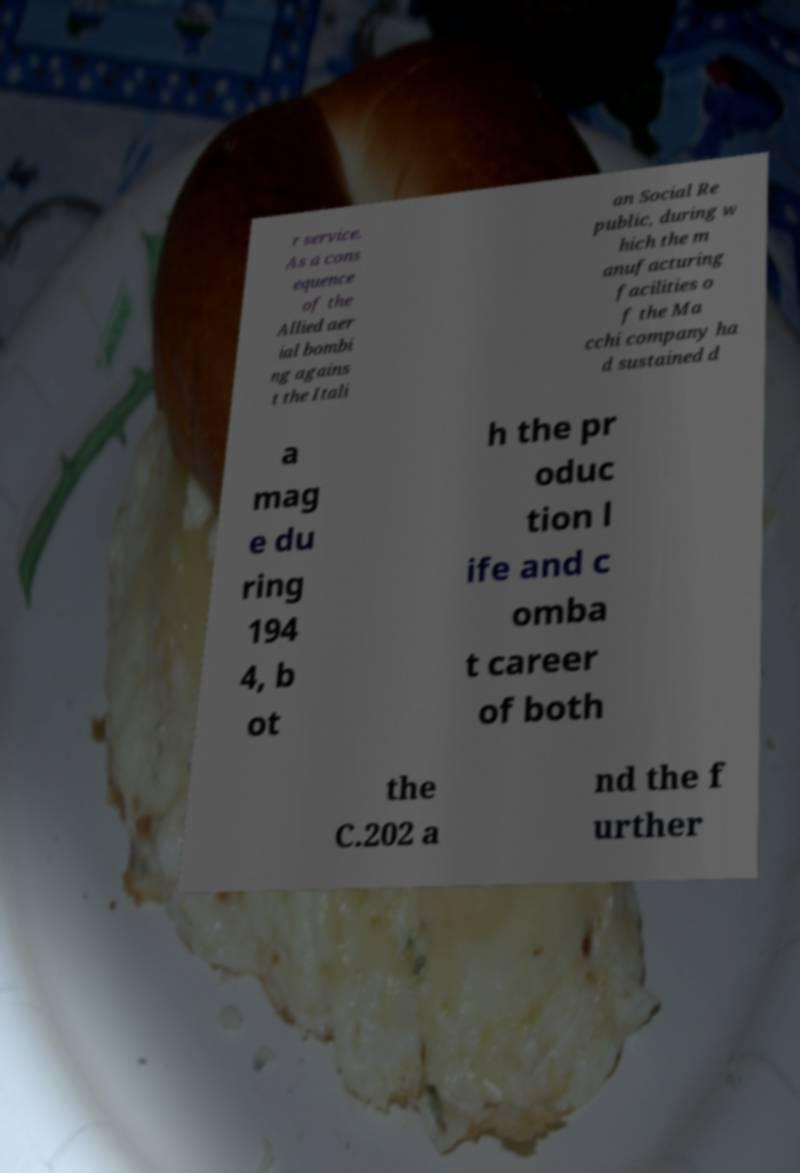Please identify and transcribe the text found in this image. r service. As a cons equence of the Allied aer ial bombi ng agains t the Itali an Social Re public, during w hich the m anufacturing facilities o f the Ma cchi company ha d sustained d a mag e du ring 194 4, b ot h the pr oduc tion l ife and c omba t career of both the C.202 a nd the f urther 